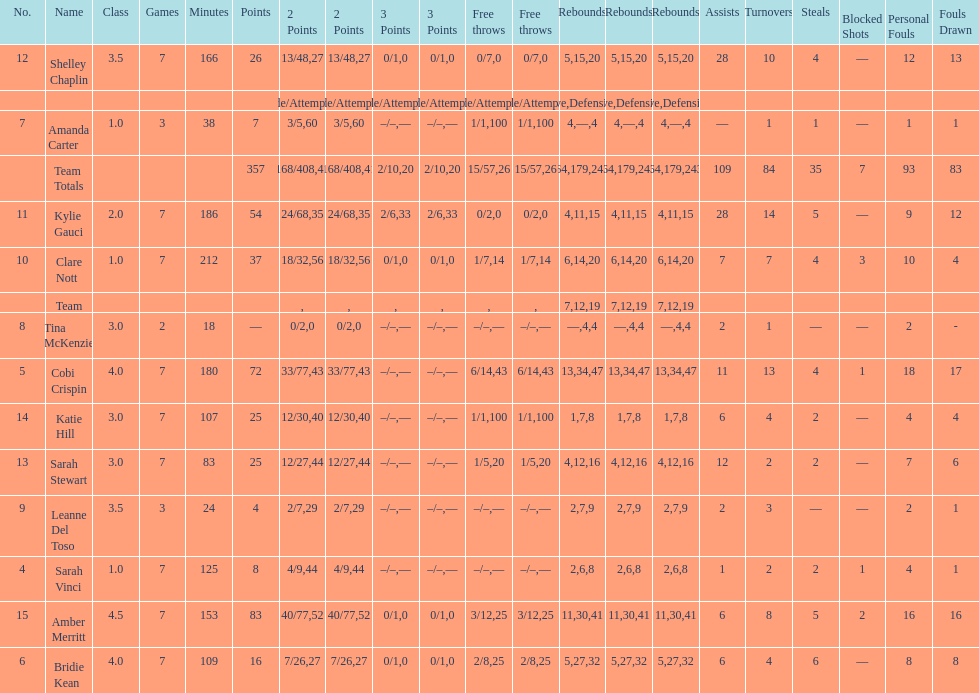Give me the full table as a dictionary. {'header': ['No.', 'Name', 'Class', 'Games', 'Minutes', 'Points', '2 Points', '2 Points', '3 Points', '3 Points', 'Free throws', 'Free throws', 'Rebounds', 'Rebounds', 'Rebounds', 'Assists', 'Turnovers', 'Steals', 'Blocked Shots', 'Personal Fouls', 'Fouls Drawn'], 'rows': [['12', 'Shelley Chaplin', '3.5', '7', '166', '26', '13/48', '27', '0/1', '0', '0/7', '0', '5', '15', '20', '28', '10', '4', '—', '12', '13'], ['', '', '', '', '', '', 'Made/Attempts', '%', 'Made/Attempts', '%', 'Made/Attempts', '%', 'Offensive', 'Defensive', 'Total', '', '', '', '', '', ''], ['7', 'Amanda Carter', '1.0', '3', '38', '7', '3/5', '60', '–/–', '—', '1/1', '100', '4', '—', '4', '—', '1', '1', '—', '1', '1'], ['', 'Team Totals', '', '', '', '357', '168/408', '41', '2/10', '20', '15/57', '26', '64', '179', '243', '109', '84', '35', '7', '93', '83'], ['11', 'Kylie Gauci', '2.0', '7', '186', '54', '24/68', '35', '2/6', '33', '0/2', '0', '4', '11', '15', '28', '14', '5', '—', '9', '12'], ['10', 'Clare Nott', '1.0', '7', '212', '37', '18/32', '56', '0/1', '0', '1/7', '14', '6', '14', '20', '7', '7', '4', '3', '10', '4'], ['', 'Team', '', '', '', '', '', '', '', '', '', '', '7', '12', '19', '', '', '', '', '', ''], ['8', 'Tina McKenzie', '3.0', '2', '18', '—', '0/2', '0', '–/–', '—', '–/–', '—', '—', '4', '4', '2', '1', '—', '—', '2', '-'], ['5', 'Cobi Crispin', '4.0', '7', '180', '72', '33/77', '43', '–/–', '—', '6/14', '43', '13', '34', '47', '11', '13', '4', '1', '18', '17'], ['14', 'Katie Hill', '3.0', '7', '107', '25', '12/30', '40', '–/–', '—', '1/1', '100', '1', '7', '8', '6', '4', '2', '—', '4', '4'], ['13', 'Sarah Stewart', '3.0', '7', '83', '25', '12/27', '44', '–/–', '—', '1/5', '20', '4', '12', '16', '12', '2', '2', '—', '7', '6'], ['9', 'Leanne Del Toso', '3.5', '3', '24', '4', '2/7', '29', '–/–', '—', '–/–', '—', '2', '7', '9', '2', '3', '—', '—', '2', '1'], ['4', 'Sarah Vinci', '1.0', '7', '125', '8', '4/9', '44', '–/–', '—', '–/–', '—', '2', '6', '8', '1', '2', '2', '1', '4', '1'], ['15', 'Amber Merritt', '4.5', '7', '153', '83', '40/77', '52', '0/1', '0', '3/12', '25', '11', '30', '41', '6', '8', '5', '2', '16', '16'], ['6', 'Bridie Kean', '4.0', '7', '109', '16', '7/26', '27', '0/1', '0', '2/8', '25', '5', '27', '32', '6', '4', '6', '—', '8', '8']]} Who holds the record for the most steals in comparison to other players? Bridie Kean. 